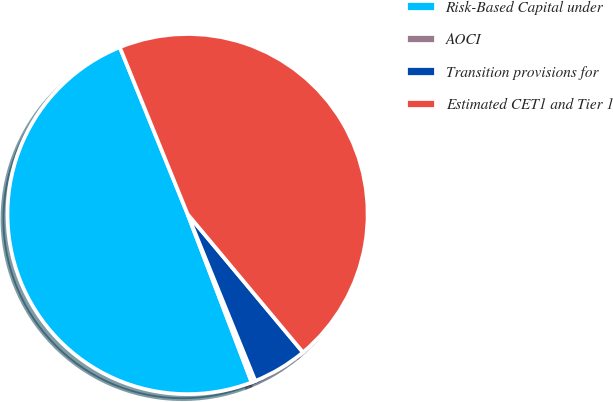<chart> <loc_0><loc_0><loc_500><loc_500><pie_chart><fcel>Risk-Based Capital under<fcel>AOCI<fcel>Transition provisions for<fcel>Estimated CET1 and Tier 1<nl><fcel>49.65%<fcel>0.35%<fcel>4.93%<fcel>45.07%<nl></chart> 